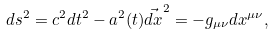<formula> <loc_0><loc_0><loc_500><loc_500>d s ^ { 2 } = c ^ { 2 } d t ^ { 2 } - a ^ { 2 } ( t ) \vec { d x } ^ { 2 } = - g _ { \mu \nu } d x ^ { \mu \nu } ,</formula> 